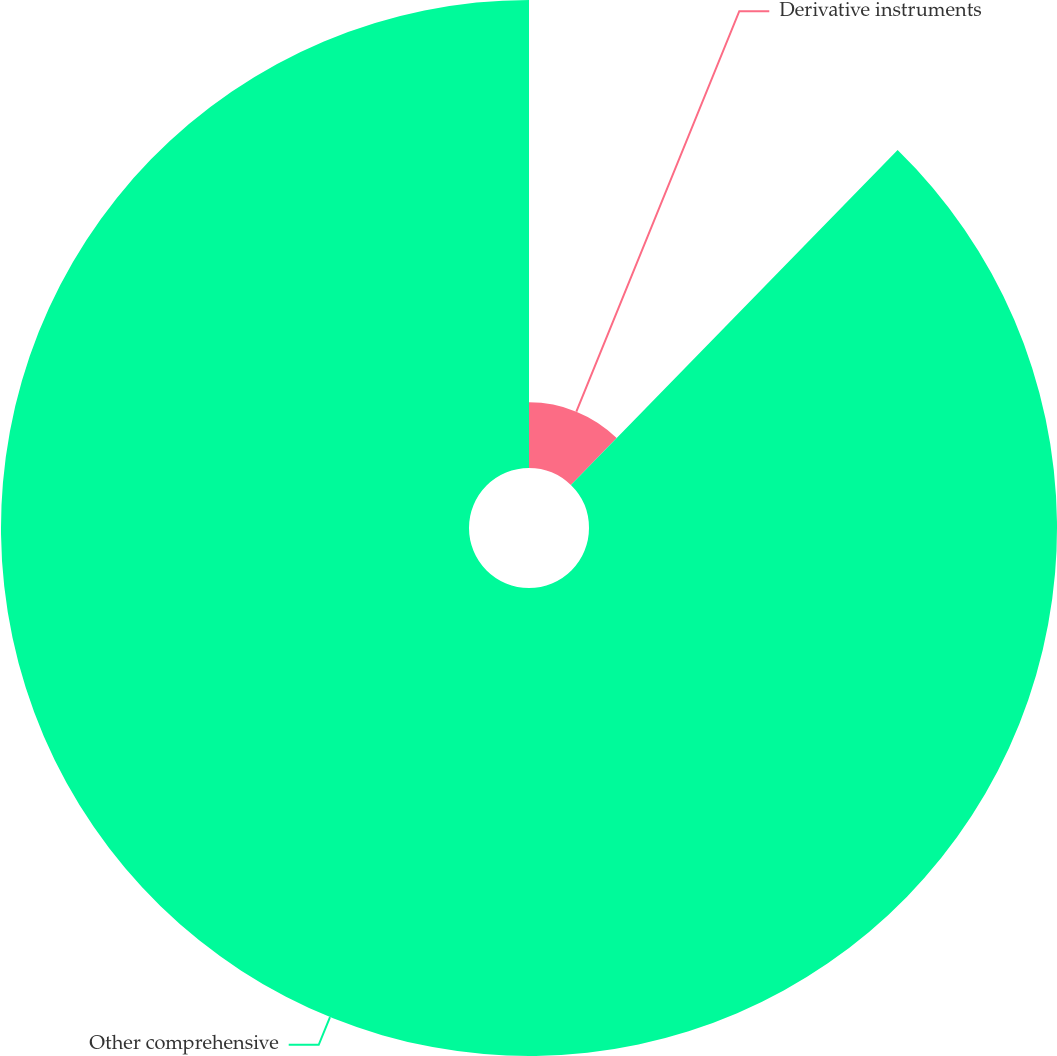<chart> <loc_0><loc_0><loc_500><loc_500><pie_chart><fcel>Derivative instruments<fcel>Other comprehensive<nl><fcel>12.3%<fcel>87.7%<nl></chart> 